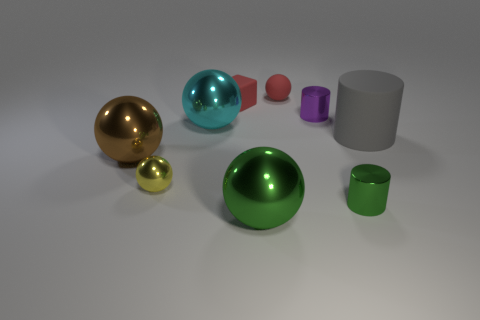The big rubber cylinder is what color?
Keep it short and to the point. Gray. There is a small rubber sphere; does it have the same color as the small cube that is behind the tiny green metallic cylinder?
Make the answer very short. Yes. There is a block that is made of the same material as the gray object; what is its size?
Your answer should be compact. Small. Is there a object that has the same color as the rubber ball?
Provide a short and direct response. Yes. How many things are green balls in front of the small purple shiny cylinder or brown things?
Provide a short and direct response. 2. Do the small block and the big thing that is on the right side of the green metallic cylinder have the same material?
Your answer should be very brief. Yes. The matte object that is the same color as the small rubber sphere is what size?
Offer a very short reply. Small. Is there a tiny green cylinder made of the same material as the big cylinder?
Offer a terse response. No. How many objects are either small objects that are in front of the tiny yellow metallic sphere or big metallic spheres behind the green cylinder?
Your answer should be very brief. 3. Is the shape of the large rubber thing the same as the tiny metal thing that is behind the tiny yellow shiny ball?
Your response must be concise. Yes. 